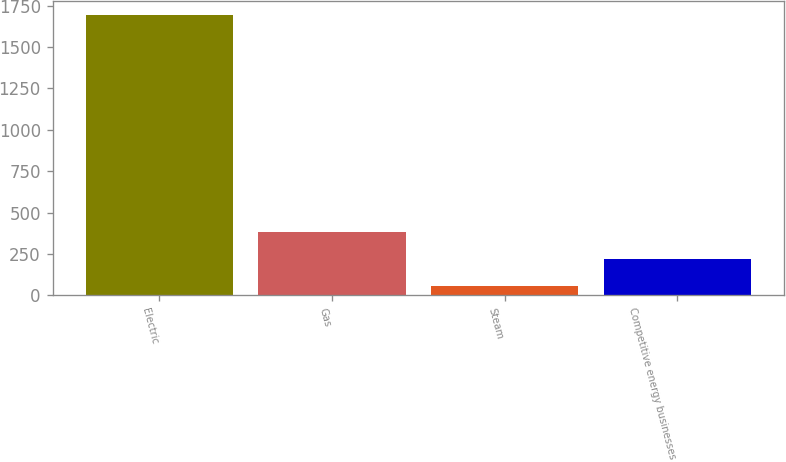Convert chart. <chart><loc_0><loc_0><loc_500><loc_500><bar_chart><fcel>Electric<fcel>Gas<fcel>Steam<fcel>Competitive energy businesses<nl><fcel>1693<fcel>381.8<fcel>54<fcel>217.9<nl></chart> 